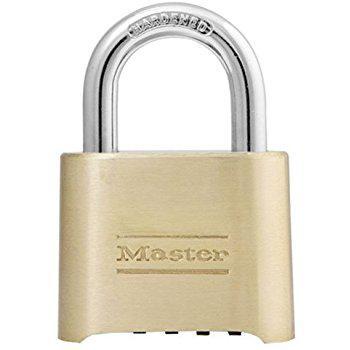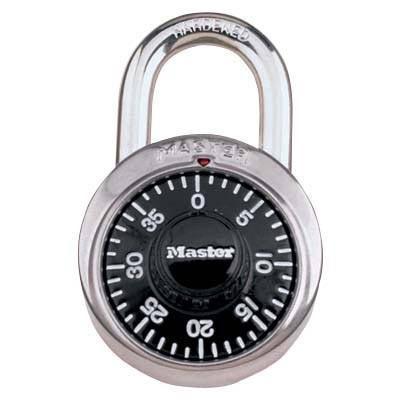The first image is the image on the left, the second image is the image on the right. Considering the images on both sides, is "One lock is gold and squarish, and the other lock is round with a black face." valid? Answer yes or no. Yes. The first image is the image on the left, the second image is the image on the right. For the images shown, is this caption "Each of two different colored padlocks is a similar shape, but one has number belts on the front and side, while the other has number belts on the bottom." true? Answer yes or no. No. 